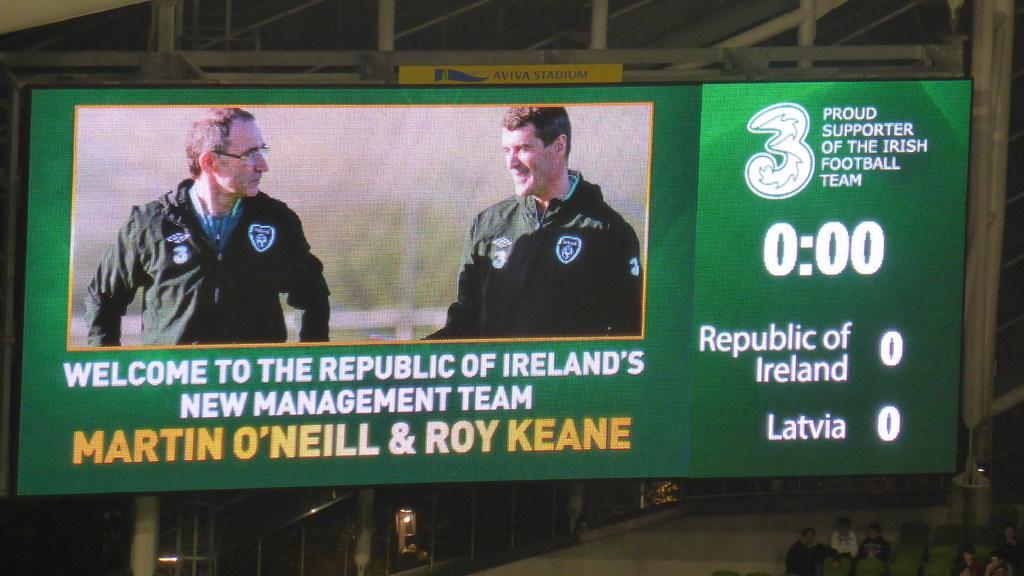Provide a one-sentence caption for the provided image. Ireland's national football team welcomes two into the new management team. 